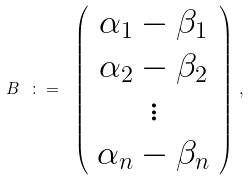Convert formula to latex. <formula><loc_0><loc_0><loc_500><loc_500>B \ \colon = \ \left ( \begin{array} { c } \alpha _ { 1 } - \beta _ { 1 } \\ \alpha _ { 2 } - \beta _ { 2 } \\ \vdots \\ \alpha _ { n } - \beta _ { n } \end{array} \right ) \, ,</formula> 